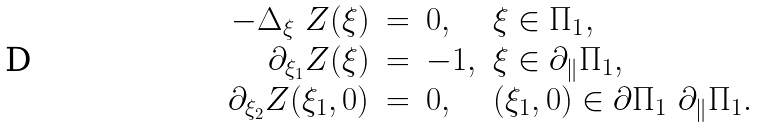<formula> <loc_0><loc_0><loc_500><loc_500>\begin{array} { r c l l } - \Delta _ { \xi } \ Z ( \xi ) & = & 0 , & \xi \in \Pi _ { 1 } , \\ \partial _ { \xi _ { 1 } } Z ( \xi ) & = & - 1 , & \xi \in \partial _ { \| } \Pi _ { 1 } , \\ \partial _ { \xi _ { 2 } } Z ( \xi _ { 1 } , 0 ) & = & 0 , & ( \xi _ { 1 } , 0 ) \in \partial \Pi _ { 1 } \ \partial _ { \| } \Pi _ { 1 } . \end{array}</formula> 